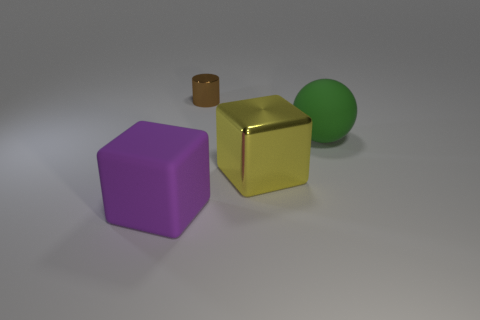What number of other objects are there of the same size as the shiny cylinder?
Your answer should be very brief. 0. There is a object to the right of the big metal block; how big is it?
Your answer should be compact. Large. The tiny object that is made of the same material as the yellow cube is what shape?
Make the answer very short. Cylinder. Is there any other thing of the same color as the large rubber block?
Make the answer very short. No. What color is the object that is to the right of the metallic thing that is in front of the tiny cylinder?
Your answer should be very brief. Green. How many big objects are either brown metal cylinders or yellow cubes?
Provide a succinct answer. 1. There is a big purple object that is the same shape as the large yellow shiny object; what is it made of?
Keep it short and to the point. Rubber. Are there any other things that are the same material as the large yellow block?
Ensure brevity in your answer.  Yes. What is the color of the small cylinder?
Ensure brevity in your answer.  Brown. Is the large shiny object the same color as the tiny cylinder?
Ensure brevity in your answer.  No. 